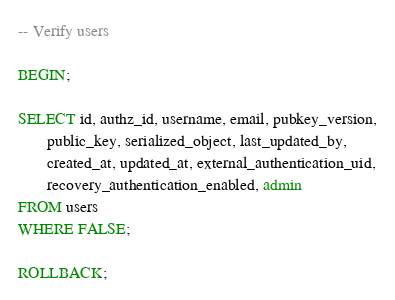Convert code to text. <code><loc_0><loc_0><loc_500><loc_500><_SQL_>-- Verify users

BEGIN;

SELECT id, authz_id, username, email, pubkey_version,
       public_key, serialized_object, last_updated_by,
       created_at, updated_at, external_authentication_uid,
       recovery_authentication_enabled, admin
FROM users
WHERE FALSE;

ROLLBACK;
</code> 